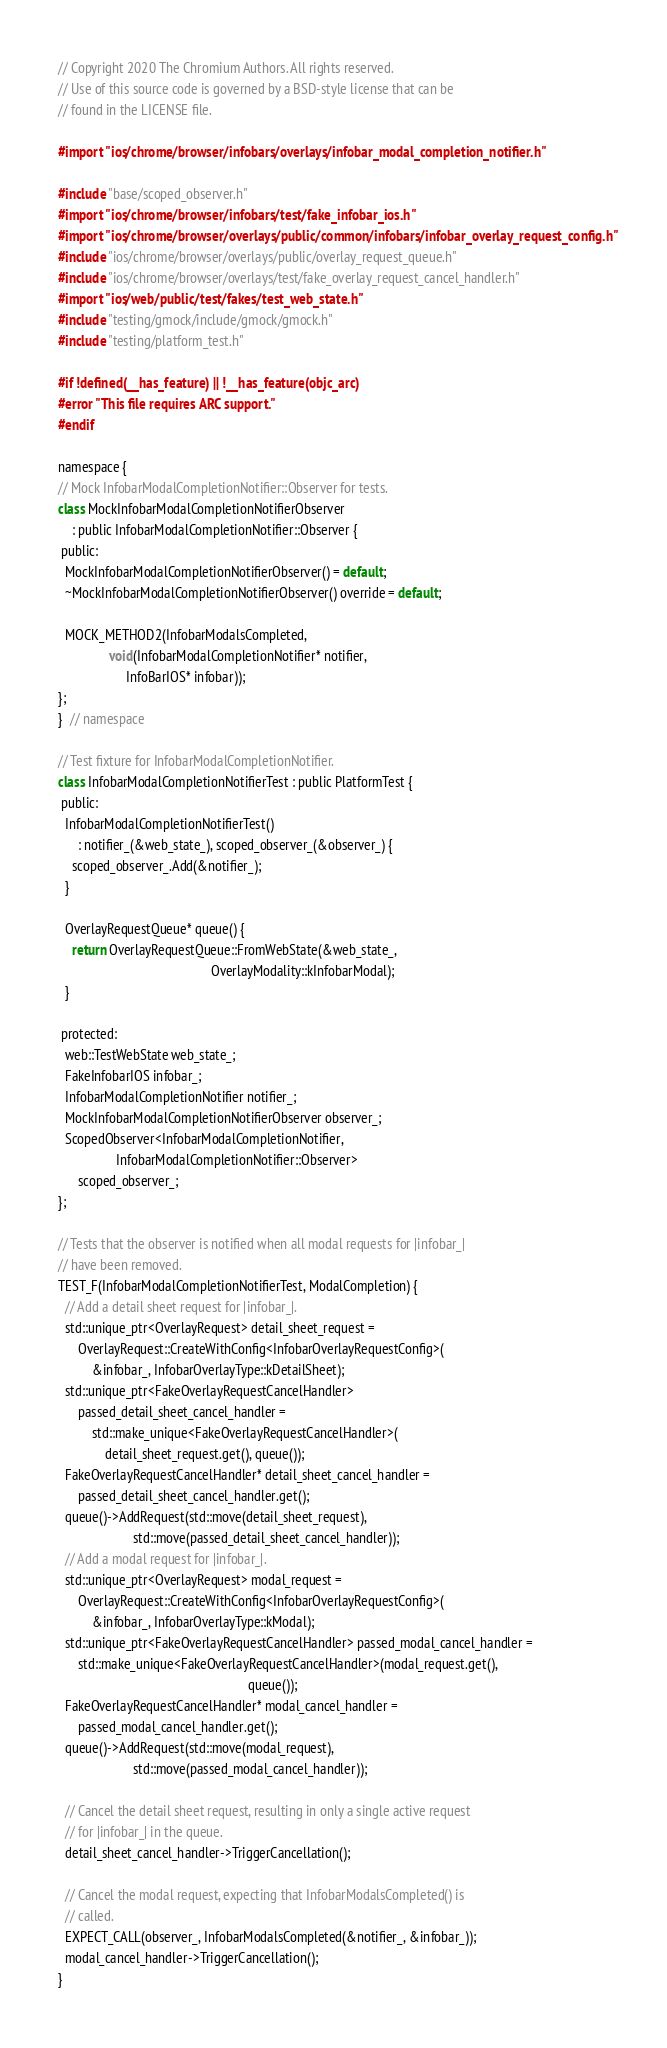Convert code to text. <code><loc_0><loc_0><loc_500><loc_500><_ObjectiveC_>// Copyright 2020 The Chromium Authors. All rights reserved.
// Use of this source code is governed by a BSD-style license that can be
// found in the LICENSE file.

#import "ios/chrome/browser/infobars/overlays/infobar_modal_completion_notifier.h"

#include "base/scoped_observer.h"
#import "ios/chrome/browser/infobars/test/fake_infobar_ios.h"
#import "ios/chrome/browser/overlays/public/common/infobars/infobar_overlay_request_config.h"
#include "ios/chrome/browser/overlays/public/overlay_request_queue.h"
#include "ios/chrome/browser/overlays/test/fake_overlay_request_cancel_handler.h"
#import "ios/web/public/test/fakes/test_web_state.h"
#include "testing/gmock/include/gmock/gmock.h"
#include "testing/platform_test.h"

#if !defined(__has_feature) || !__has_feature(objc_arc)
#error "This file requires ARC support."
#endif

namespace {
// Mock InfobarModalCompletionNotifier::Observer for tests.
class MockInfobarModalCompletionNotifierObserver
    : public InfobarModalCompletionNotifier::Observer {
 public:
  MockInfobarModalCompletionNotifierObserver() = default;
  ~MockInfobarModalCompletionNotifierObserver() override = default;

  MOCK_METHOD2(InfobarModalsCompleted,
               void(InfobarModalCompletionNotifier* notifier,
                    InfoBarIOS* infobar));
};
}  // namespace

// Test fixture for InfobarModalCompletionNotifier.
class InfobarModalCompletionNotifierTest : public PlatformTest {
 public:
  InfobarModalCompletionNotifierTest()
      : notifier_(&web_state_), scoped_observer_(&observer_) {
    scoped_observer_.Add(&notifier_);
  }

  OverlayRequestQueue* queue() {
    return OverlayRequestQueue::FromWebState(&web_state_,
                                             OverlayModality::kInfobarModal);
  }

 protected:
  web::TestWebState web_state_;
  FakeInfobarIOS infobar_;
  InfobarModalCompletionNotifier notifier_;
  MockInfobarModalCompletionNotifierObserver observer_;
  ScopedObserver<InfobarModalCompletionNotifier,
                 InfobarModalCompletionNotifier::Observer>
      scoped_observer_;
};

// Tests that the observer is notified when all modal requests for |infobar_|
// have been removed.
TEST_F(InfobarModalCompletionNotifierTest, ModalCompletion) {
  // Add a detail sheet request for |infobar_|.
  std::unique_ptr<OverlayRequest> detail_sheet_request =
      OverlayRequest::CreateWithConfig<InfobarOverlayRequestConfig>(
          &infobar_, InfobarOverlayType::kDetailSheet);
  std::unique_ptr<FakeOverlayRequestCancelHandler>
      passed_detail_sheet_cancel_handler =
          std::make_unique<FakeOverlayRequestCancelHandler>(
              detail_sheet_request.get(), queue());
  FakeOverlayRequestCancelHandler* detail_sheet_cancel_handler =
      passed_detail_sheet_cancel_handler.get();
  queue()->AddRequest(std::move(detail_sheet_request),
                      std::move(passed_detail_sheet_cancel_handler));
  // Add a modal request for |infobar_|.
  std::unique_ptr<OverlayRequest> modal_request =
      OverlayRequest::CreateWithConfig<InfobarOverlayRequestConfig>(
          &infobar_, InfobarOverlayType::kModal);
  std::unique_ptr<FakeOverlayRequestCancelHandler> passed_modal_cancel_handler =
      std::make_unique<FakeOverlayRequestCancelHandler>(modal_request.get(),
                                                        queue());
  FakeOverlayRequestCancelHandler* modal_cancel_handler =
      passed_modal_cancel_handler.get();
  queue()->AddRequest(std::move(modal_request),
                      std::move(passed_modal_cancel_handler));

  // Cancel the detail sheet request, resulting in only a single active request
  // for |infobar_| in the queue.
  detail_sheet_cancel_handler->TriggerCancellation();

  // Cancel the modal request, expecting that InfobarModalsCompleted() is
  // called.
  EXPECT_CALL(observer_, InfobarModalsCompleted(&notifier_, &infobar_));
  modal_cancel_handler->TriggerCancellation();
}
</code> 